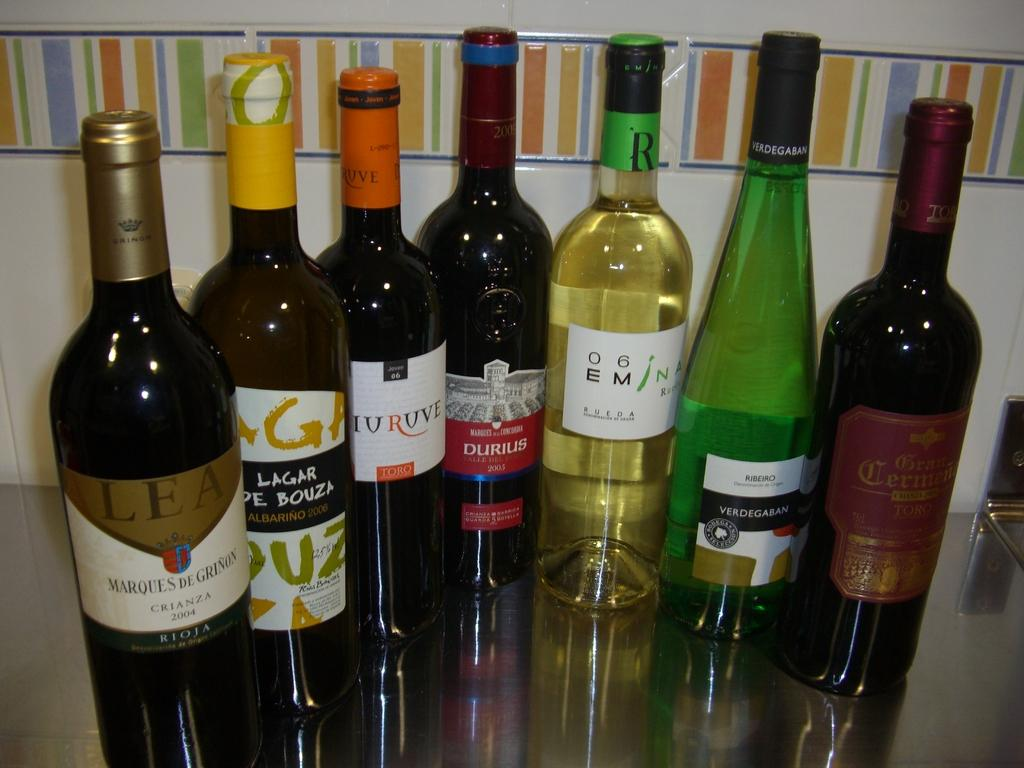<image>
Create a compact narrative representing the image presented. Some bottles of wine with titles like DURIUS. 